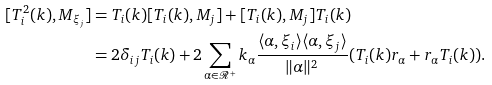<formula> <loc_0><loc_0><loc_500><loc_500>[ T _ { i } ^ { 2 } ( k ) , M _ { \xi _ { j } } ] & = T _ { i } ( k ) [ T _ { i } ( k ) , M _ { j } ] + [ T _ { i } ( k ) , M _ { j } ] T _ { i } ( k ) \\ & = 2 \delta _ { i j } T _ { i } ( k ) + 2 \sum _ { \alpha \in \mathcal { R } ^ { + } } k _ { \alpha } \frac { \langle \alpha , \xi _ { i } \rangle \langle \alpha , \xi _ { j } \rangle } { \| \alpha \| ^ { 2 } } ( T _ { i } ( k ) r _ { \alpha } + r _ { \alpha } T _ { i } ( k ) ) .</formula> 